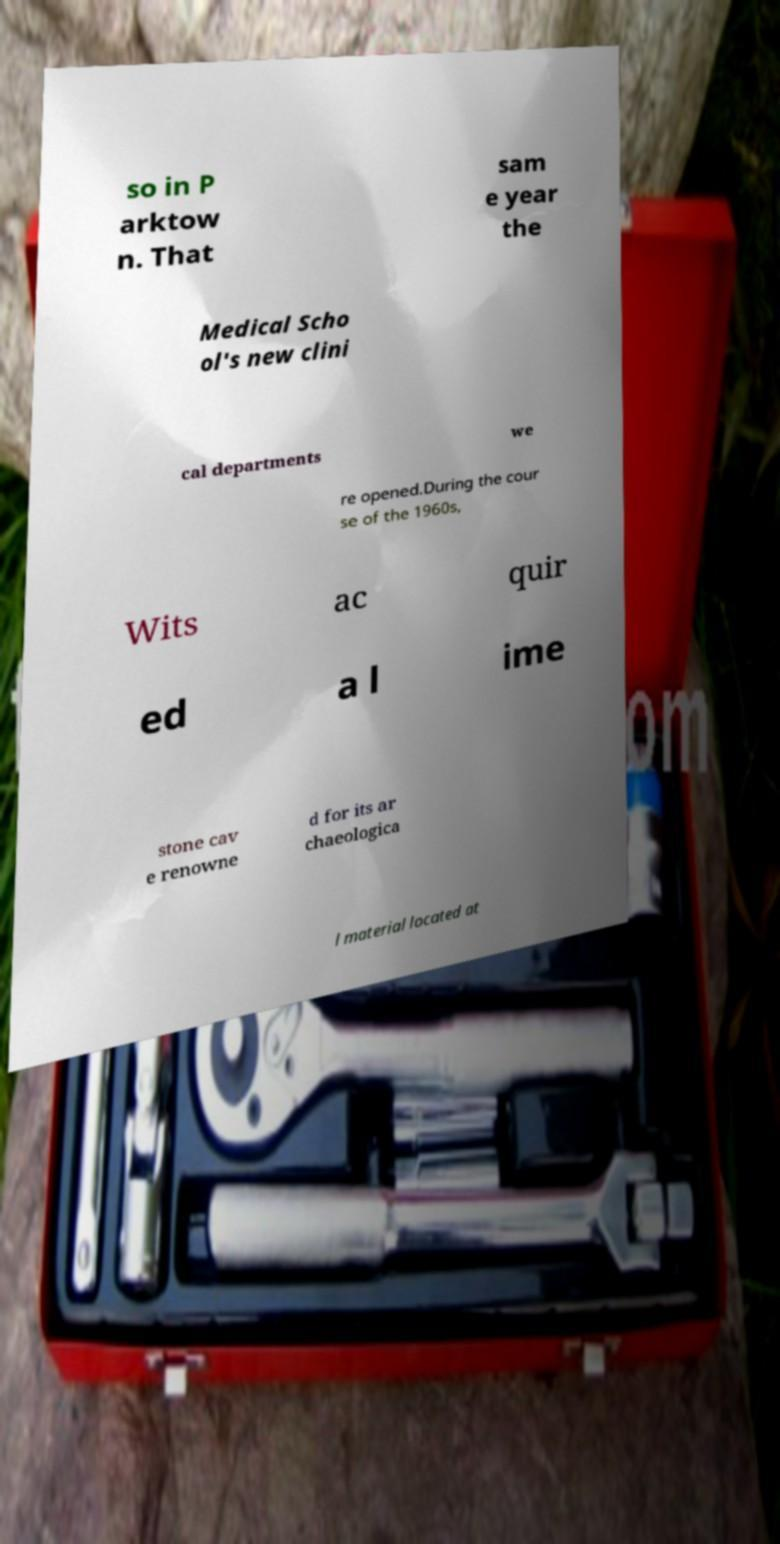I need the written content from this picture converted into text. Can you do that? so in P arktow n. That sam e year the Medical Scho ol's new clini cal departments we re opened.During the cour se of the 1960s, Wits ac quir ed a l ime stone cav e renowne d for its ar chaeologica l material located at 